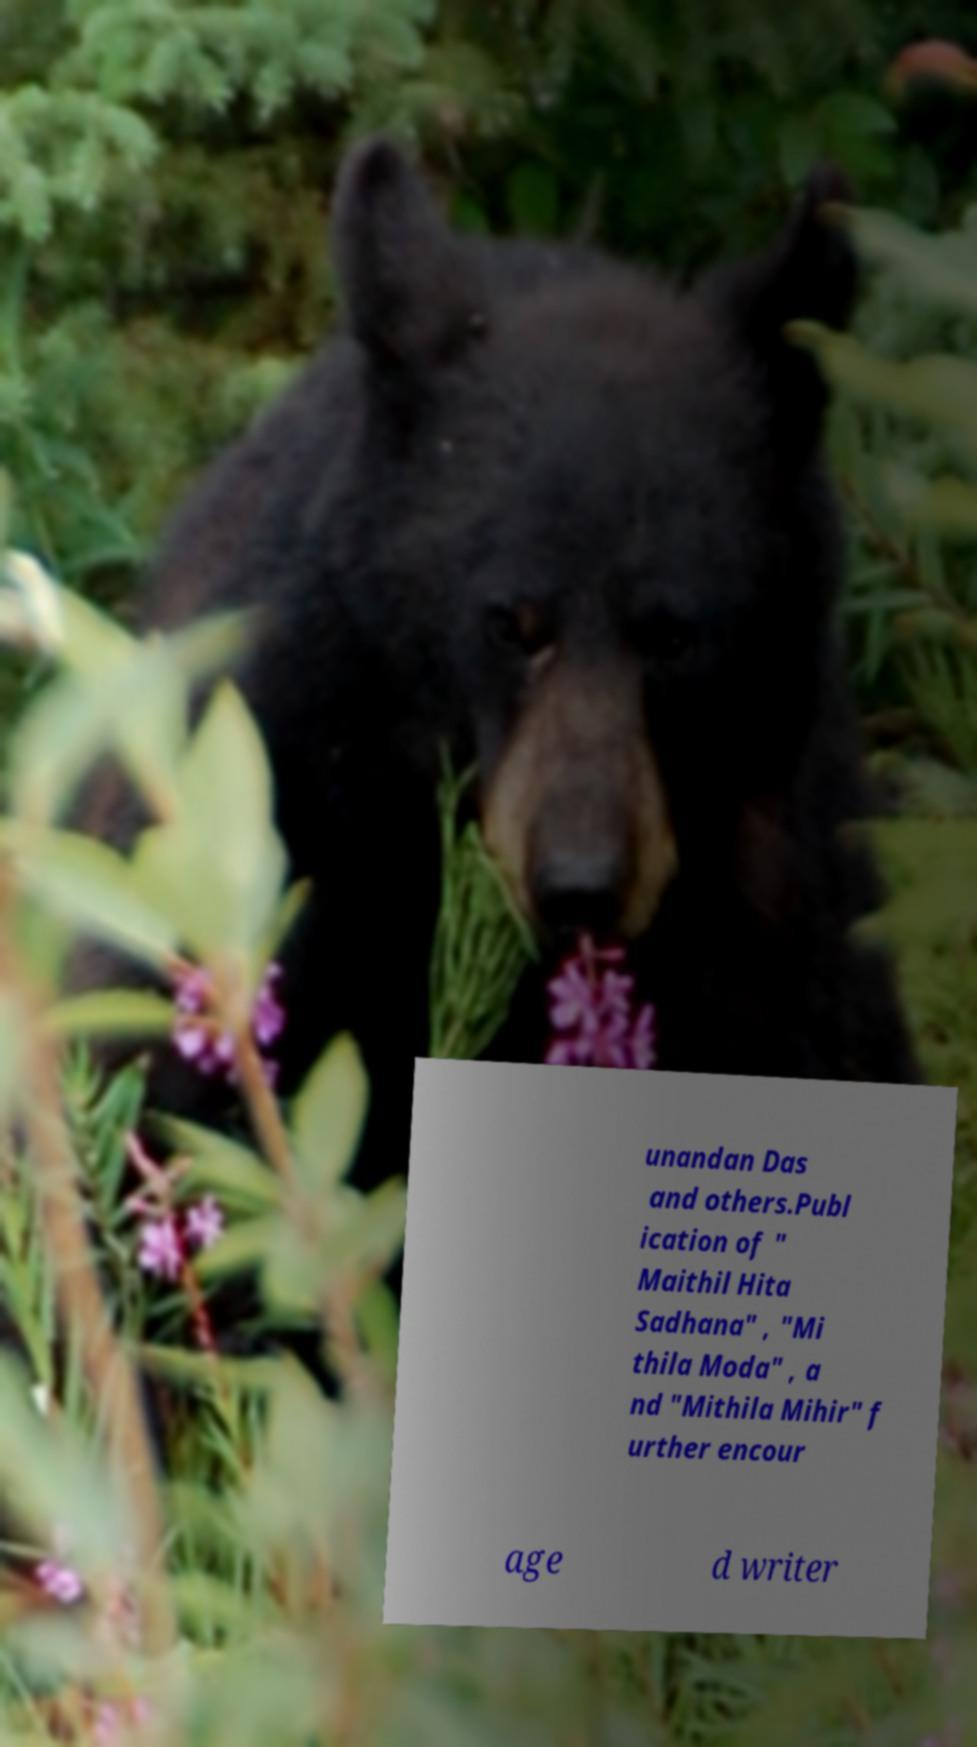Could you extract and type out the text from this image? unandan Das and others.Publ ication of " Maithil Hita Sadhana" , "Mi thila Moda" , a nd "Mithila Mihir" f urther encour age d writer 